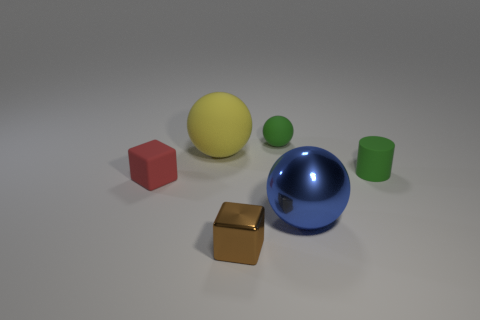What number of other objects are there of the same shape as the big yellow matte object?
Provide a short and direct response. 2. Is the material of the tiny object on the left side of the brown thing the same as the green sphere?
Give a very brief answer. Yes. Are there an equal number of small green rubber objects that are on the right side of the yellow rubber thing and small matte things on the left side of the tiny matte cylinder?
Give a very brief answer. Yes. How big is the sphere that is in front of the big rubber ball?
Provide a short and direct response. Large. Is there a big yellow object made of the same material as the small sphere?
Ensure brevity in your answer.  Yes. There is a rubber ball to the right of the brown metallic block; is it the same color as the tiny matte cylinder?
Keep it short and to the point. Yes. Is the number of yellow objects that are left of the tiny rubber block the same as the number of small gray metal cylinders?
Ensure brevity in your answer.  Yes. Are there any tiny rubber cylinders of the same color as the big metallic ball?
Provide a short and direct response. No. Do the red block and the green cylinder have the same size?
Keep it short and to the point. Yes. What is the size of the ball in front of the rubber thing that is left of the big yellow matte sphere?
Offer a very short reply. Large. 